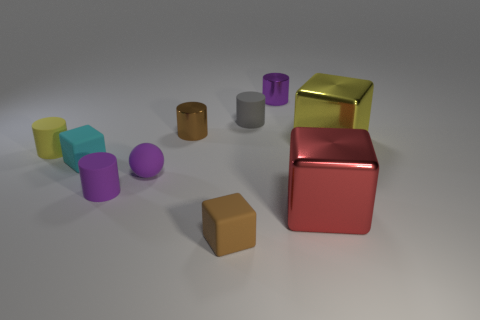Subtract all small gray cylinders. How many cylinders are left? 4 Subtract all yellow cylinders. How many cylinders are left? 4 Subtract 1 yellow cylinders. How many objects are left? 9 Subtract all spheres. How many objects are left? 9 Subtract 5 cylinders. How many cylinders are left? 0 Subtract all yellow cubes. Subtract all gray spheres. How many cubes are left? 3 Subtract all red cubes. How many green balls are left? 0 Subtract all big cyan metal things. Subtract all big yellow metal things. How many objects are left? 9 Add 6 big red blocks. How many big red blocks are left? 7 Add 2 small yellow metal spheres. How many small yellow metal spheres exist? 2 